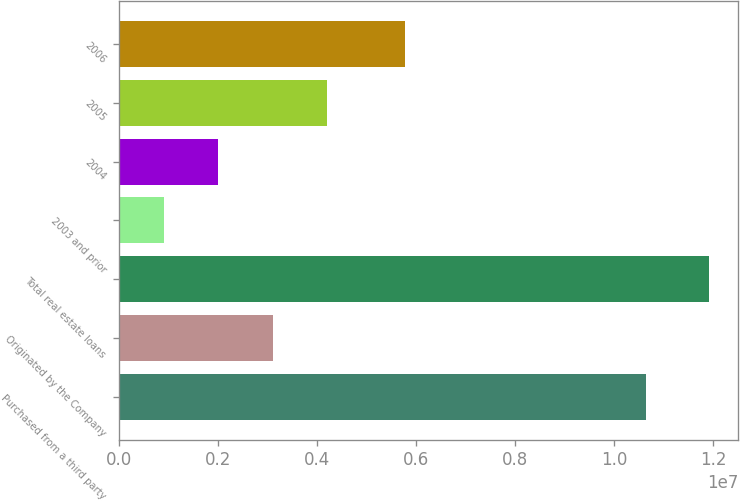Convert chart to OTSL. <chart><loc_0><loc_0><loc_500><loc_500><bar_chart><fcel>Purchased from a third party<fcel>Originated by the Company<fcel>Total real estate loans<fcel>2003 and prior<fcel>2004<fcel>2005<fcel>2006<nl><fcel>1.0638e+07<fcel>3.10126e+06<fcel>1.19013e+07<fcel>901240<fcel>2.00125e+06<fcel>4.20127e+06<fcel>5.76091e+06<nl></chart> 